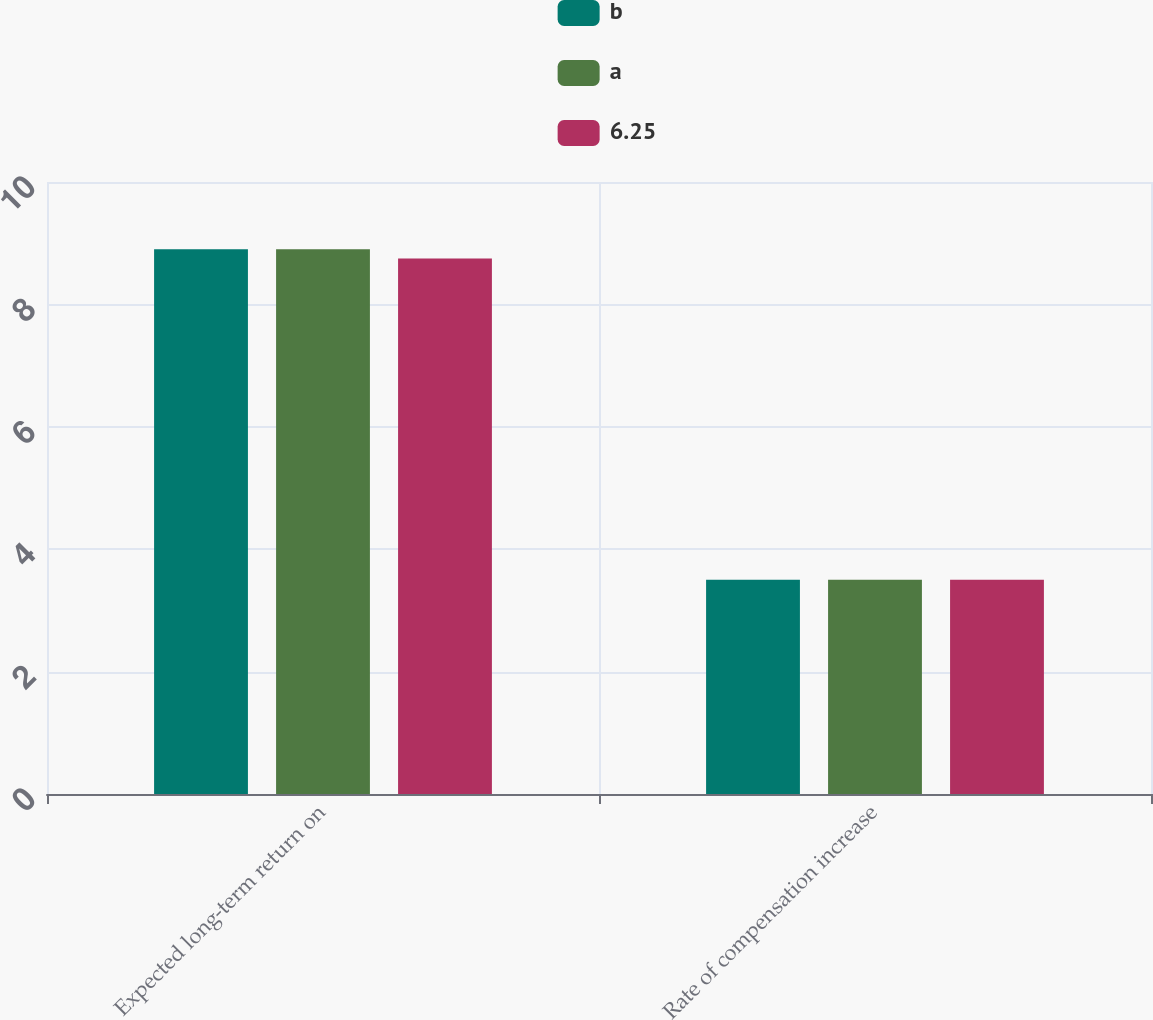Convert chart to OTSL. <chart><loc_0><loc_0><loc_500><loc_500><stacked_bar_chart><ecel><fcel>Expected long-term return on<fcel>Rate of compensation increase<nl><fcel>b<fcel>8.9<fcel>3.5<nl><fcel>a<fcel>8.9<fcel>3.5<nl><fcel>6.25<fcel>8.75<fcel>3.5<nl></chart> 